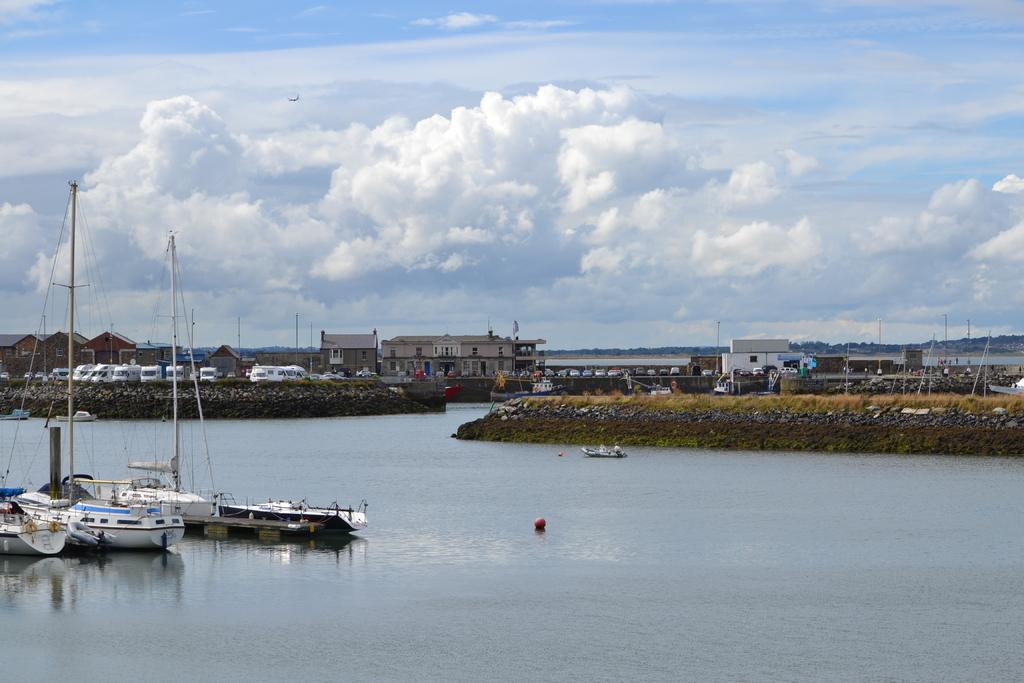What is the main subject in the center of the image? There are ships in the center of the image. What is the location of the ships? The ships are on water. What can be seen in the background of the image? There are cars, buildings, and poles in the background of the image. How would you describe the sky in the image? The sky is cloudy in the image. How many birds are flying over the ships in the image? There are no birds visible in the image; it only features ships on water, cars, buildings, poles, and a cloudy sky. 